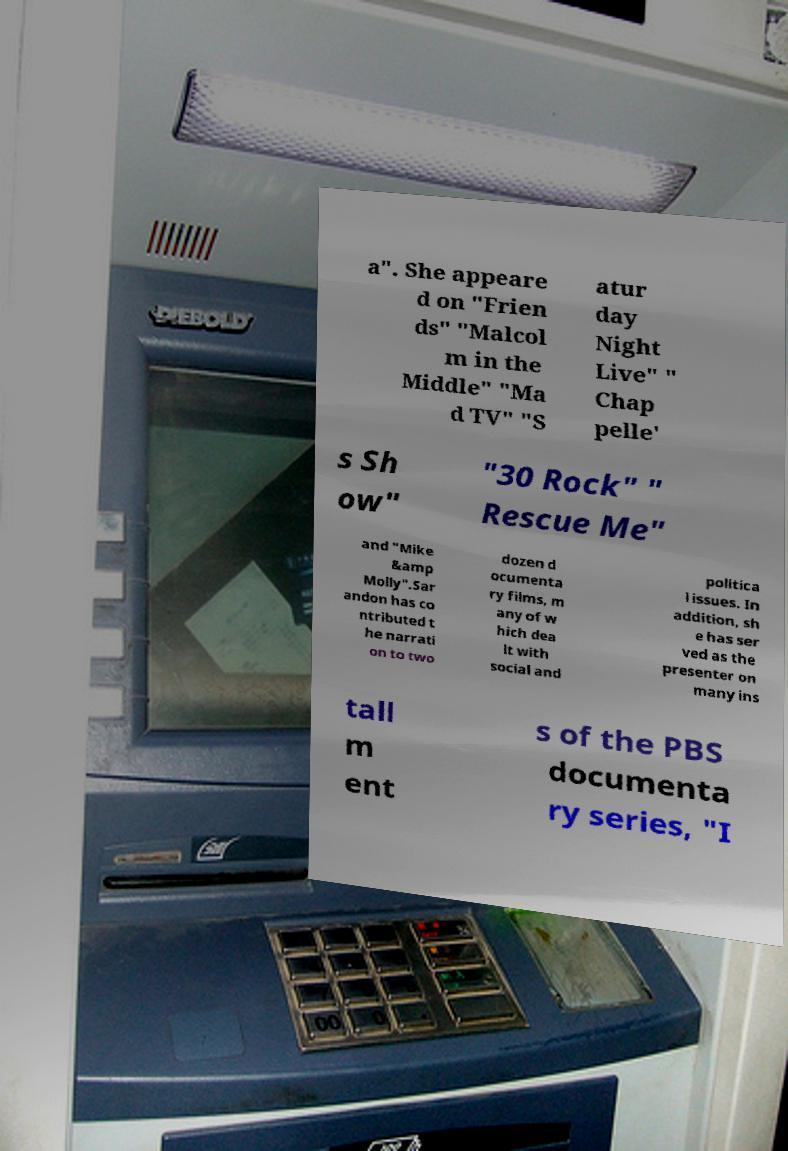There's text embedded in this image that I need extracted. Can you transcribe it verbatim? a". She appeare d on "Frien ds" "Malcol m in the Middle" "Ma d TV" "S atur day Night Live" " Chap pelle' s Sh ow" "30 Rock" " Rescue Me" and "Mike &amp Molly".Sar andon has co ntributed t he narrati on to two dozen d ocumenta ry films, m any of w hich dea lt with social and politica l issues. In addition, sh e has ser ved as the presenter on many ins tall m ent s of the PBS documenta ry series, "I 